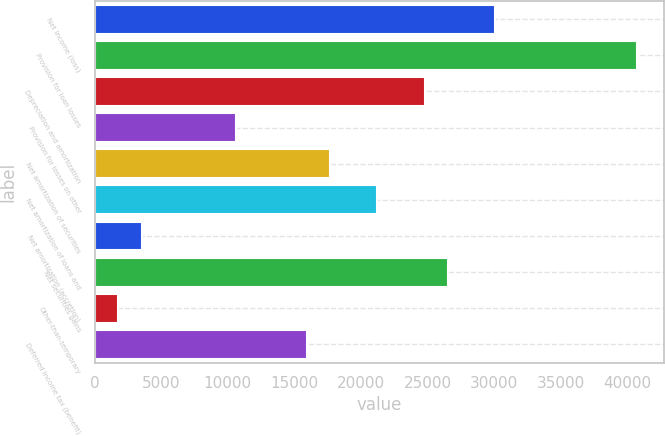<chart> <loc_0><loc_0><loc_500><loc_500><bar_chart><fcel>Net income (loss)<fcel>Provision for loan losses<fcel>Depreciation and amortization<fcel>Provision for losses on other<fcel>Net amortization of securities<fcel>Net amortization of loans and<fcel>Net amortization (accretion)<fcel>Net securities gains<fcel>Other-than-temporary<fcel>Deferred income tax (benefit)<nl><fcel>30091<fcel>40711<fcel>24781<fcel>10621<fcel>17701<fcel>21241<fcel>3541<fcel>26551<fcel>1771<fcel>15931<nl></chart> 